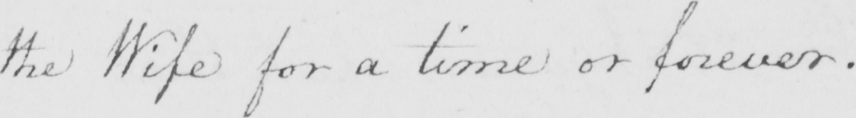Can you read and transcribe this handwriting? the Wife for a time or forever . 